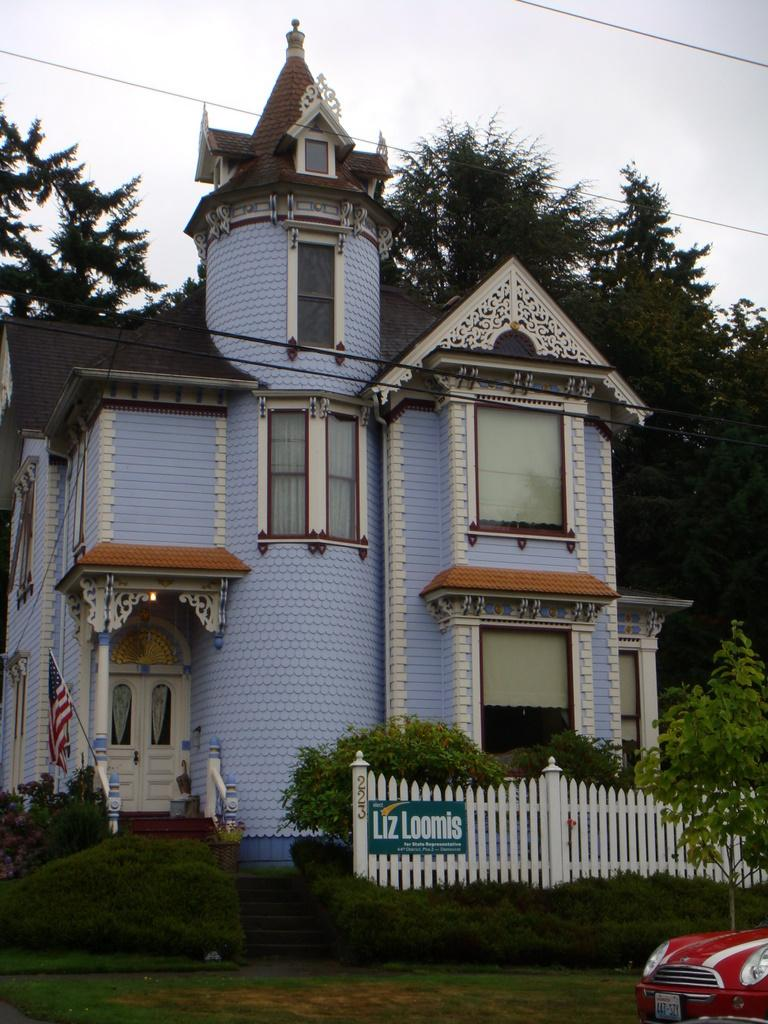What type of structure is present in the image? There is a building in the image. What can be seen in the background behind the building? Trees are visible behind the building. How is the ground around the building depicted? The ground is covered with plants, bushes, and grass. Is there any transportation visible in the image? Yes, there is a car parked on the road in front of the building. What type of trousers is the building wearing in the image? Buildings do not wear trousers, as they are inanimate objects. 